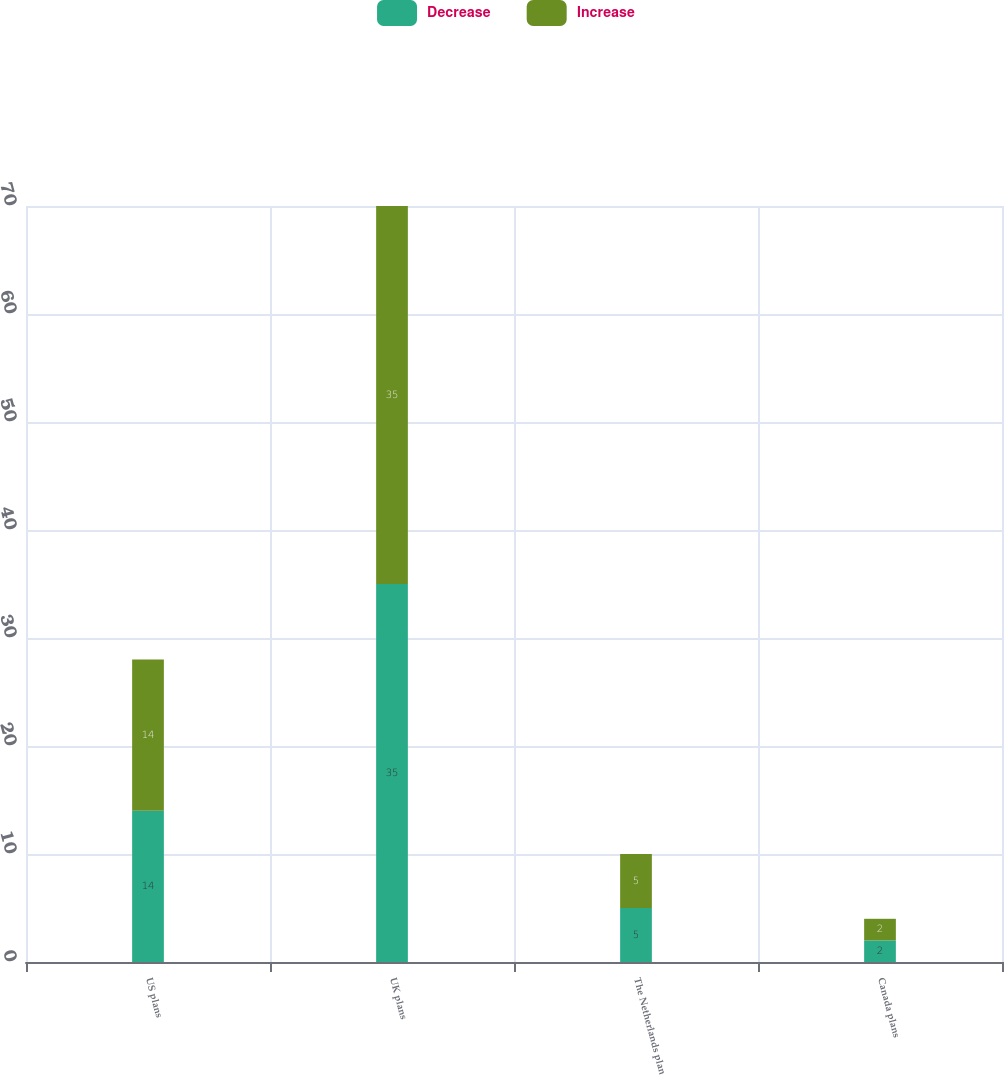Convert chart. <chart><loc_0><loc_0><loc_500><loc_500><stacked_bar_chart><ecel><fcel>US plans<fcel>UK plans<fcel>The Netherlands plan<fcel>Canada plans<nl><fcel>Decrease<fcel>14<fcel>35<fcel>5<fcel>2<nl><fcel>Increase<fcel>14<fcel>35<fcel>5<fcel>2<nl></chart> 